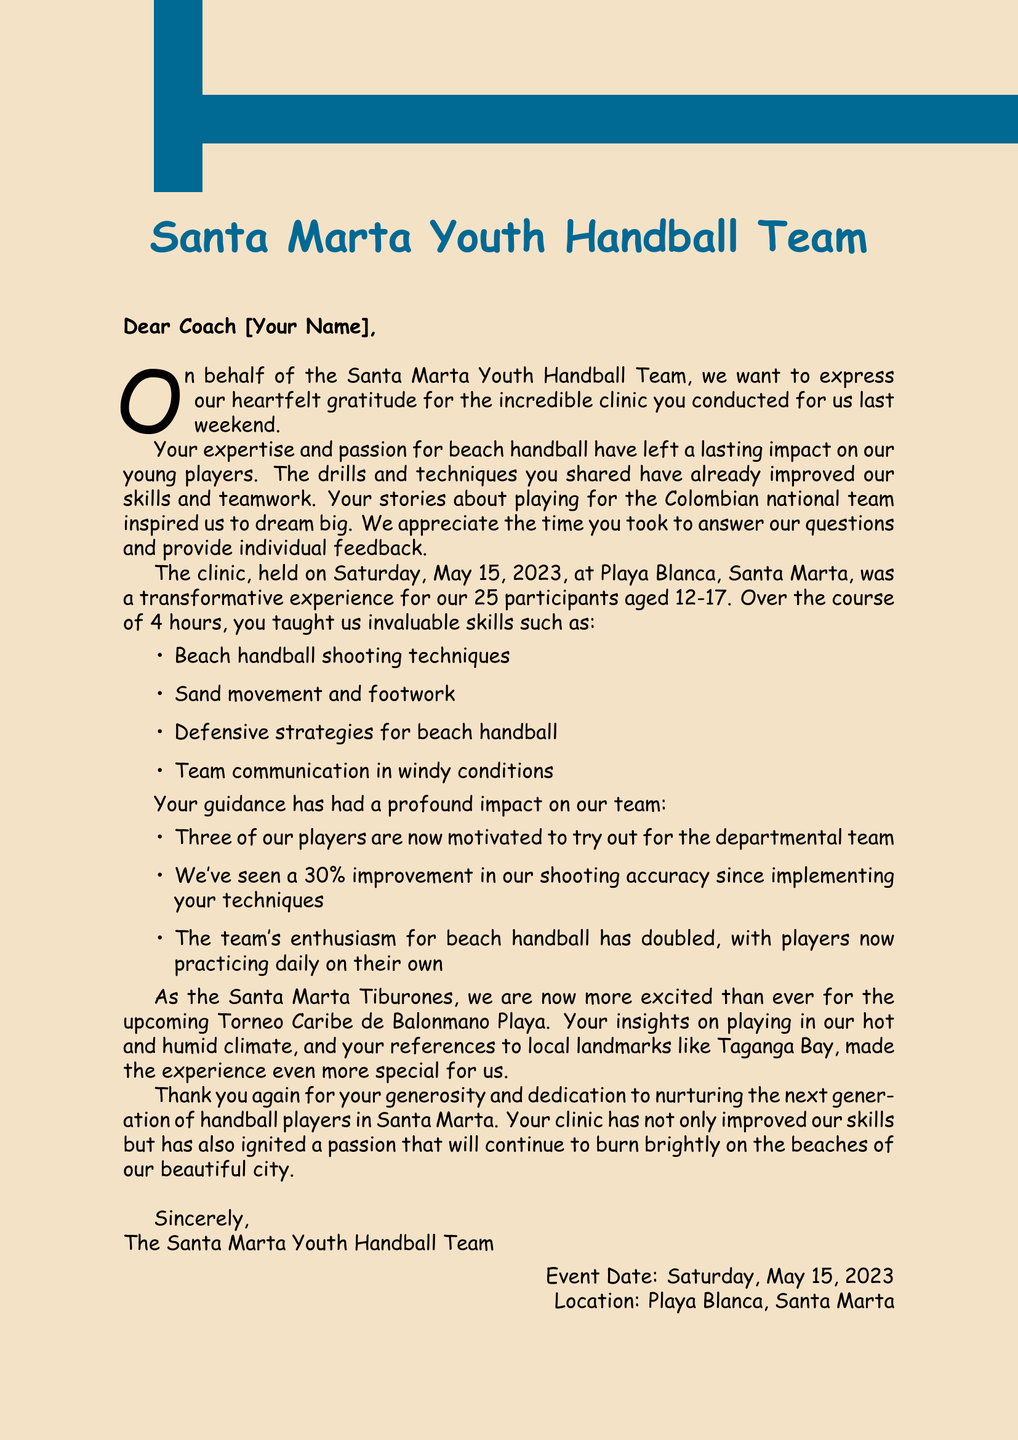What is the name of the youth handball team? The letter explicitly states that it is the "Santa Marta Youth Handball Team."
Answer: Santa Marta Youth Handball Team What date was the clinic held? The letter includes the specific date as "Saturday, May 15, 2023."
Answer: Saturday, May 15, 2023 How many participants attended the clinic? The letter mentions that there were "25 participants" at the clinic.
Answer: 25 participants What is one of the skills taught during the clinic? The document lists several skills, including "Beach handball shooting techniques."
Answer: Beach handball shooting techniques Who is the coach of the local team mentioned? The letter refers to "Maria Fernanda Rodríguez" as the coach.
Answer: Maria Fernanda Rodríguez What has been the improvement in shooting accuracy? One of the impact statements notes a "30% improvement in our shooting accuracy."
Answer: 30% Which local tournament are they looking forward to? The letter mentions the "Torneo Caribe de Balonmano Playa" as an upcoming event.
Answer: Torneo Caribe de Balonmano Playa What is one of the emotional impacts of the clinic on the players? The letter states that the clinic has "motivated three of our players to try out for the departmental team."
Answer: Motivated three players What is the location of the clinic? The document specifies that the clinic took place at "Playa Blanca, Santa Marta."
Answer: Playa Blanca, Santa Marta 